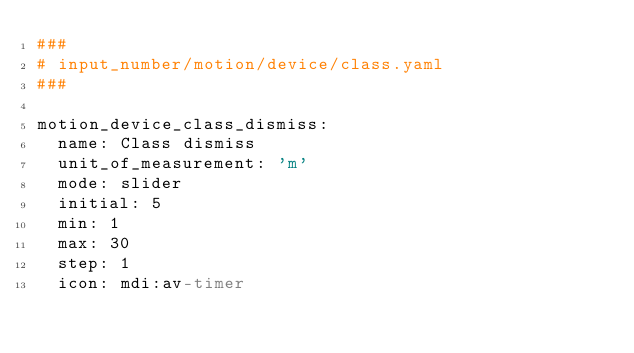Convert code to text. <code><loc_0><loc_0><loc_500><loc_500><_YAML_>###
# input_number/motion/device/class.yaml
###

motion_device_class_dismiss:
  name: Class dismiss
  unit_of_measurement: 'm'
  mode: slider
  initial: 5
  min: 1
  max: 30
  step: 1
  icon: mdi:av-timer
</code> 